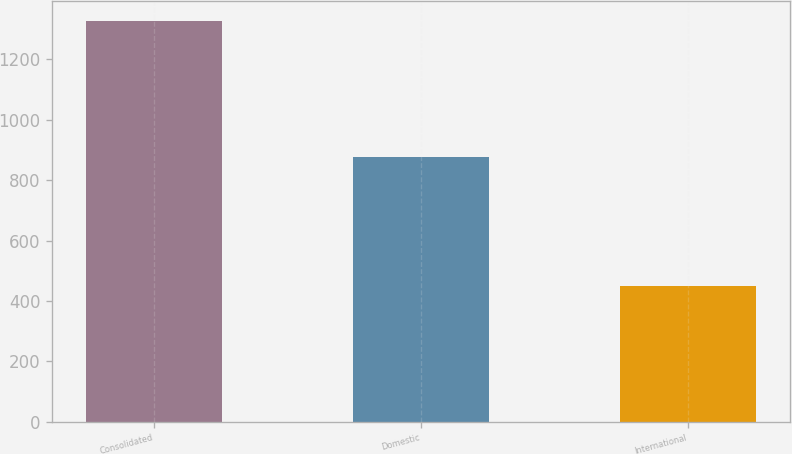Convert chart to OTSL. <chart><loc_0><loc_0><loc_500><loc_500><bar_chart><fcel>Consolidated<fcel>Domestic<fcel>International<nl><fcel>1326.7<fcel>878.6<fcel>448.1<nl></chart> 